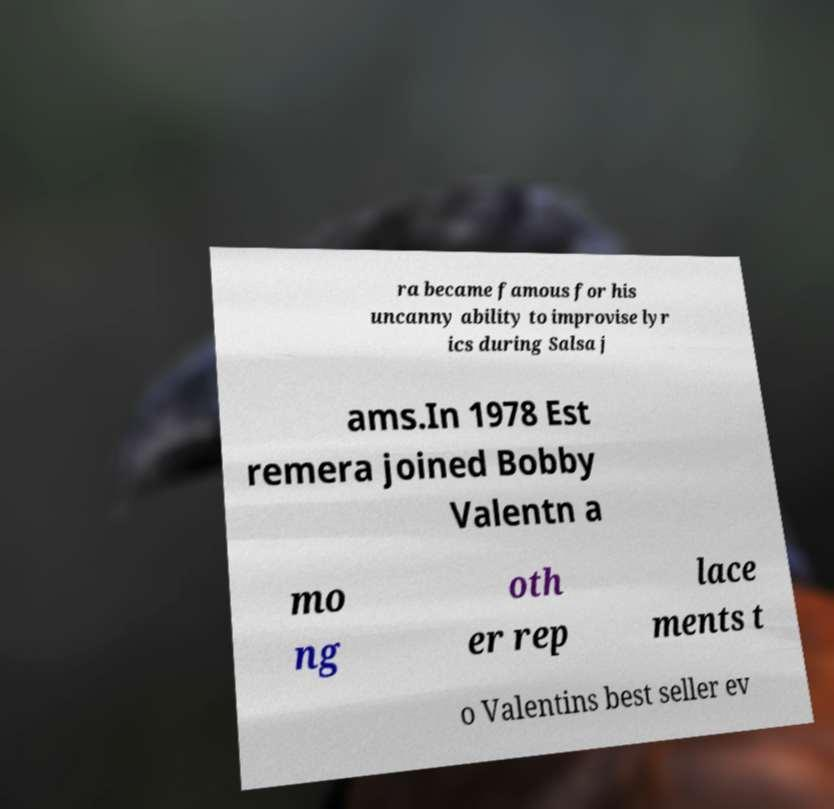Please read and relay the text visible in this image. What does it say? ra became famous for his uncanny ability to improvise lyr ics during Salsa j ams.In 1978 Est remera joined Bobby Valentn a mo ng oth er rep lace ments t o Valentins best seller ev 